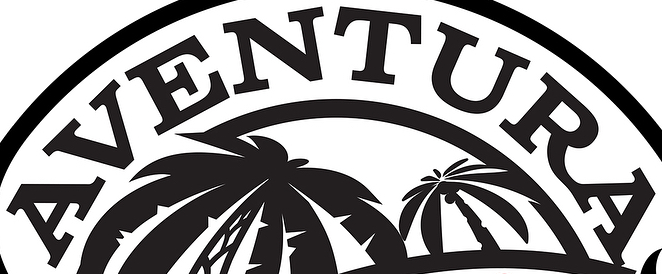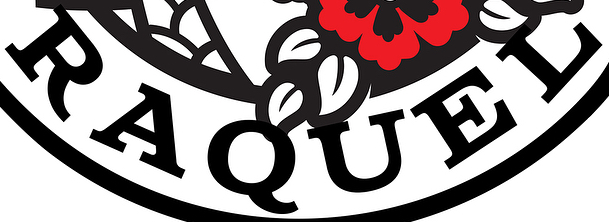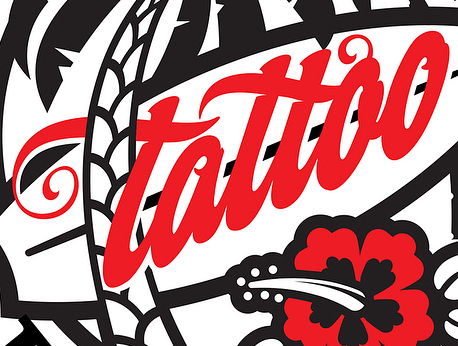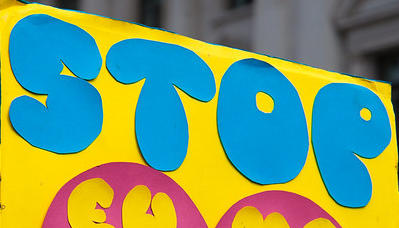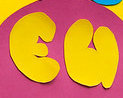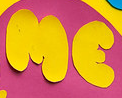Transcribe the words shown in these images in order, separated by a semicolon. AVENTURA; RAQUEL; tattao; STOP; EU; ME 